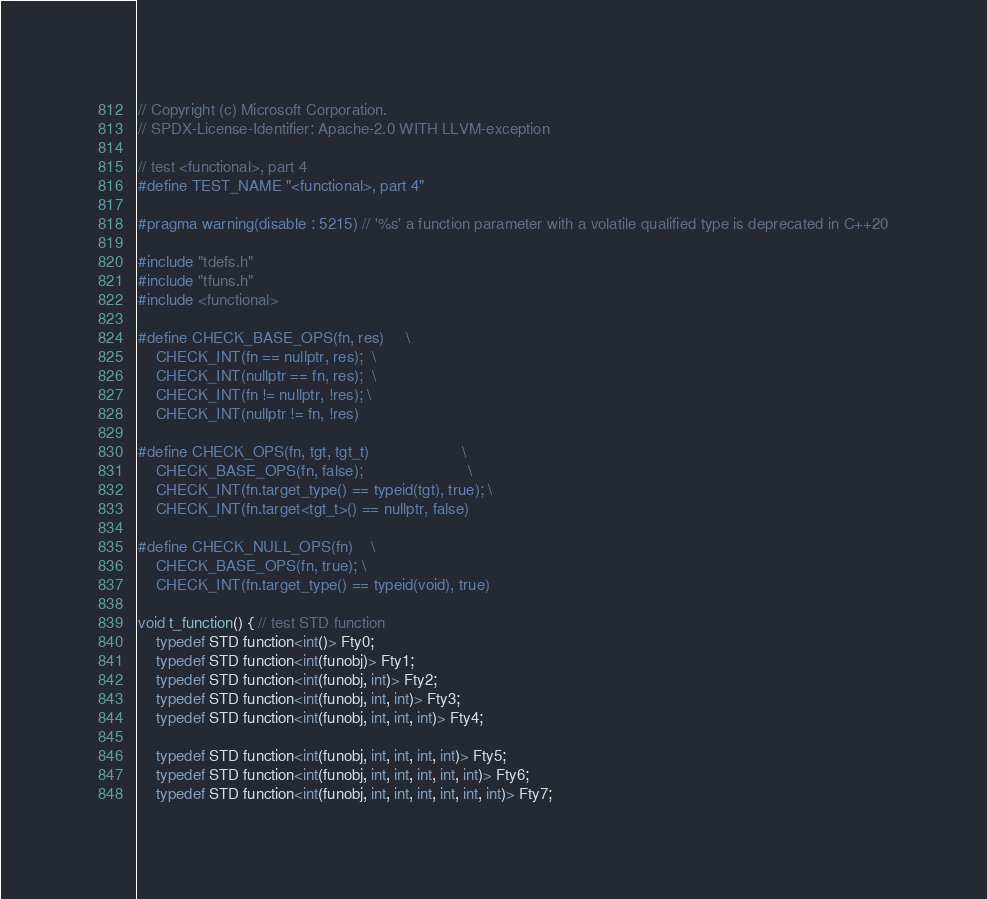<code> <loc_0><loc_0><loc_500><loc_500><_C++_>// Copyright (c) Microsoft Corporation.
// SPDX-License-Identifier: Apache-2.0 WITH LLVM-exception

// test <functional>, part 4
#define TEST_NAME "<functional>, part 4"

#pragma warning(disable : 5215) // '%s' a function parameter with a volatile qualified type is deprecated in C++20

#include "tdefs.h"
#include "tfuns.h"
#include <functional>

#define CHECK_BASE_OPS(fn, res)     \
    CHECK_INT(fn == nullptr, res);  \
    CHECK_INT(nullptr == fn, res);  \
    CHECK_INT(fn != nullptr, !res); \
    CHECK_INT(nullptr != fn, !res)

#define CHECK_OPS(fn, tgt, tgt_t)                     \
    CHECK_BASE_OPS(fn, false);                        \
    CHECK_INT(fn.target_type() == typeid(tgt), true); \
    CHECK_INT(fn.target<tgt_t>() == nullptr, false)

#define CHECK_NULL_OPS(fn)    \
    CHECK_BASE_OPS(fn, true); \
    CHECK_INT(fn.target_type() == typeid(void), true)

void t_function() { // test STD function
    typedef STD function<int()> Fty0;
    typedef STD function<int(funobj)> Fty1;
    typedef STD function<int(funobj, int)> Fty2;
    typedef STD function<int(funobj, int, int)> Fty3;
    typedef STD function<int(funobj, int, int, int)> Fty4;

    typedef STD function<int(funobj, int, int, int, int)> Fty5;
    typedef STD function<int(funobj, int, int, int, int, int)> Fty6;
    typedef STD function<int(funobj, int, int, int, int, int, int)> Fty7;</code> 